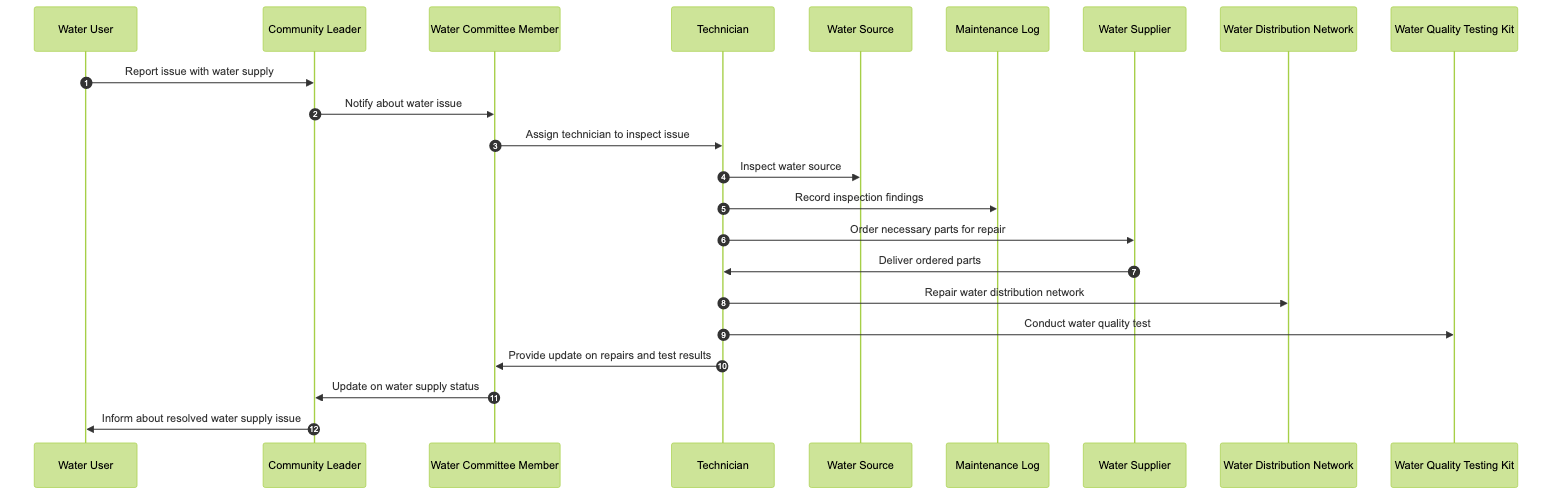What is the first action taken in the sequence? The first action is when the Water User reports an issue with the water supply to the Community Leader. This is indicated as the first message in the diagram, showing the direction and relationship between these two actors.
Answer: Report issue with water supply How many actors are involved in the diagram? The diagram includes five actors: Community Leader, Water Committee Member, Technician, Water User, and Water Supplier. This can be verified by counting the unique participant entries listed at the beginning of the sequence.
Answer: Five What message does the Water Committee Member send after assigning the technician? After assigning the technician, the Water Committee Member provides an update on repairs and test results to the Community Leader. This can be tracked in the sequence of messages following the technician assignment.
Answer: Provide update on repairs and test results What does the Technician do after delivering ordered parts? After delivering the ordered parts, the Technician repairs the water distribution network. This action is directly linked following the message's sequence, indicating the continuity in the repair process.
Answer: Repair water distribution network How many messages are exchanged between the Technician and the Water Committee Member? There are two messages exchanged between the Technician and the Water Committee Member: one about providing an update on repairs and the other about assigning the technician. This can be determined by counting the arrows connecting these two roles in the sequence.
Answer: Two What is the last action performed in the sequence? The last action is the Community Leader informing the Water User about the resolved water supply issue. This message concludes the sequence, reflecting the end of the process in managing the water supply concern.
Answer: Inform about resolved water supply issue What is the role of the Maintenance Log in the context of this diagram? The Maintenance Log is used by the Technician to record inspection findings. This highlights the importance of documentation in the process of addressing water supply issues as shown in the sequence.
Answer: Record inspection findings What does the Water Supplier deliver to the Technician? The Water Supplier delivers ordered parts to the Technician. This delivery is necessary for the subsequent action where the Technician repairs the water distribution network.
Answer: Deliver ordered parts What action does the Technician take to ensure the water quality? The Technician conducts a water quality test. This action is essential in determining the safety and usability of the water after repairs have been made, located in the sequence of actions undertaken by the Technician.
Answer: Conduct water quality test 